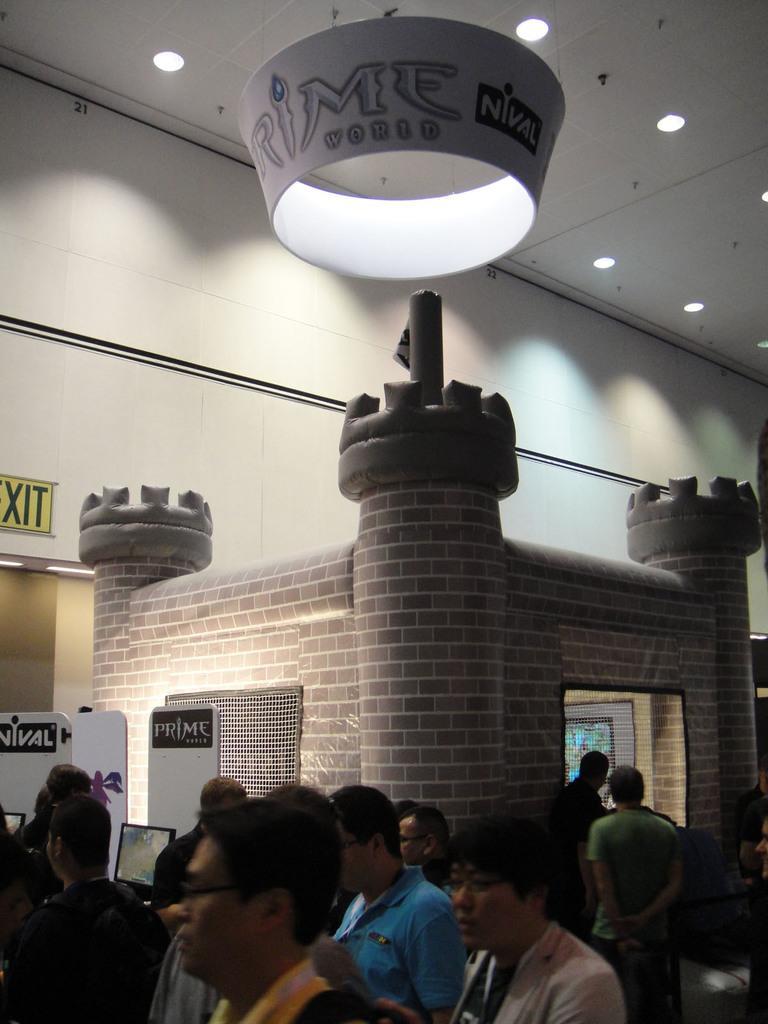Describe this image in one or two sentences. In this image we can see some group of persons standing in a room and in the background of the image there is a fort shape and top of the image there are some lights and roof. 